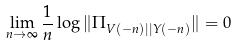<formula> <loc_0><loc_0><loc_500><loc_500>\lim _ { n \to \infty } \frac { 1 } { n } \log \| \Pi _ { V ( - n ) | | Y ( - n ) } \| = 0</formula> 